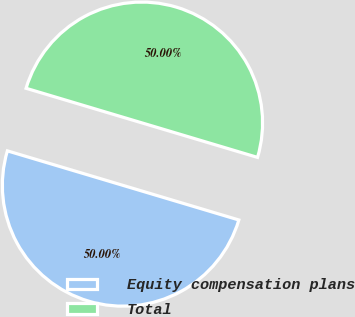<chart> <loc_0><loc_0><loc_500><loc_500><pie_chart><fcel>Equity compensation plans<fcel>Total<nl><fcel>50.0%<fcel>50.0%<nl></chart> 